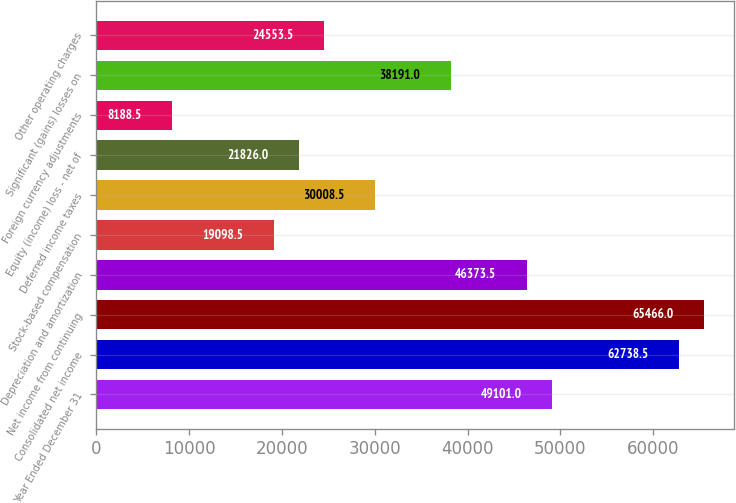Convert chart. <chart><loc_0><loc_0><loc_500><loc_500><bar_chart><fcel>Year Ended December 31<fcel>Consolidated net income<fcel>Net income from continuing<fcel>Depreciation and amortization<fcel>Stock-based compensation<fcel>Deferred income taxes<fcel>Equity (income) loss - net of<fcel>Foreign currency adjustments<fcel>Significant (gains) losses on<fcel>Other operating charges<nl><fcel>49101<fcel>62738.5<fcel>65466<fcel>46373.5<fcel>19098.5<fcel>30008.5<fcel>21826<fcel>8188.5<fcel>38191<fcel>24553.5<nl></chart> 